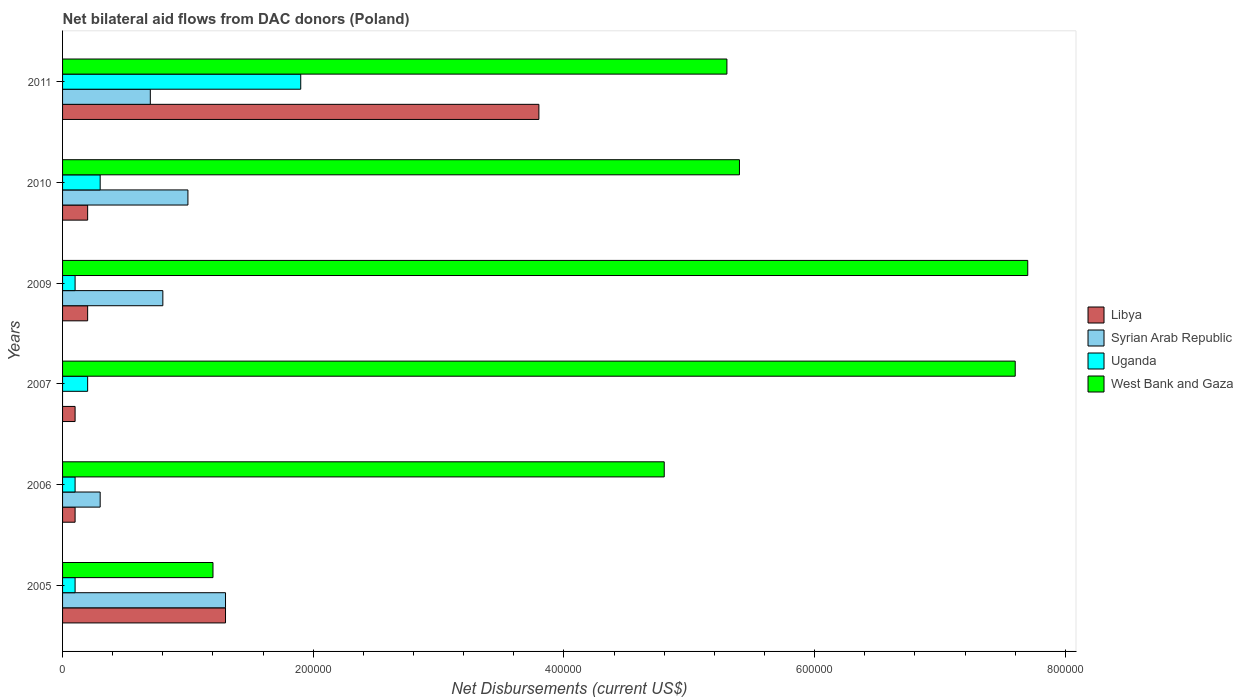How many groups of bars are there?
Keep it short and to the point. 6. Are the number of bars on each tick of the Y-axis equal?
Give a very brief answer. No. How many bars are there on the 1st tick from the bottom?
Offer a terse response. 4. In how many cases, is the number of bars for a given year not equal to the number of legend labels?
Make the answer very short. 1. What is the net bilateral aid flows in West Bank and Gaza in 2011?
Offer a terse response. 5.30e+05. Across all years, what is the maximum net bilateral aid flows in Uganda?
Offer a terse response. 1.90e+05. What is the difference between the net bilateral aid flows in Syrian Arab Republic in 2010 and the net bilateral aid flows in West Bank and Gaza in 2005?
Provide a succinct answer. -2.00e+04. What is the average net bilateral aid flows in West Bank and Gaza per year?
Offer a very short reply. 5.33e+05. In how many years, is the net bilateral aid flows in Libya greater than 760000 US$?
Your answer should be very brief. 0. What is the ratio of the net bilateral aid flows in West Bank and Gaza in 2005 to that in 2010?
Offer a terse response. 0.22. Is the net bilateral aid flows in Libya in 2007 less than that in 2009?
Keep it short and to the point. Yes. What is the difference between the highest and the lowest net bilateral aid flows in Syrian Arab Republic?
Provide a succinct answer. 1.30e+05. How many bars are there?
Give a very brief answer. 23. How many years are there in the graph?
Offer a terse response. 6. What is the difference between two consecutive major ticks on the X-axis?
Your answer should be compact. 2.00e+05. Are the values on the major ticks of X-axis written in scientific E-notation?
Provide a short and direct response. No. How are the legend labels stacked?
Offer a very short reply. Vertical. What is the title of the graph?
Offer a very short reply. Net bilateral aid flows from DAC donors (Poland). What is the label or title of the X-axis?
Offer a terse response. Net Disbursements (current US$). What is the Net Disbursements (current US$) of Uganda in 2005?
Make the answer very short. 10000. What is the Net Disbursements (current US$) of Libya in 2006?
Keep it short and to the point. 10000. What is the Net Disbursements (current US$) of Syrian Arab Republic in 2006?
Offer a terse response. 3.00e+04. What is the Net Disbursements (current US$) of Uganda in 2006?
Offer a terse response. 10000. What is the Net Disbursements (current US$) of Libya in 2007?
Make the answer very short. 10000. What is the Net Disbursements (current US$) of Uganda in 2007?
Offer a very short reply. 2.00e+04. What is the Net Disbursements (current US$) of West Bank and Gaza in 2007?
Ensure brevity in your answer.  7.60e+05. What is the Net Disbursements (current US$) of Libya in 2009?
Make the answer very short. 2.00e+04. What is the Net Disbursements (current US$) in Syrian Arab Republic in 2009?
Provide a succinct answer. 8.00e+04. What is the Net Disbursements (current US$) of Uganda in 2009?
Give a very brief answer. 10000. What is the Net Disbursements (current US$) of West Bank and Gaza in 2009?
Provide a short and direct response. 7.70e+05. What is the Net Disbursements (current US$) of Libya in 2010?
Your answer should be compact. 2.00e+04. What is the Net Disbursements (current US$) in Syrian Arab Republic in 2010?
Your response must be concise. 1.00e+05. What is the Net Disbursements (current US$) in West Bank and Gaza in 2010?
Keep it short and to the point. 5.40e+05. What is the Net Disbursements (current US$) in Syrian Arab Republic in 2011?
Your response must be concise. 7.00e+04. What is the Net Disbursements (current US$) in West Bank and Gaza in 2011?
Ensure brevity in your answer.  5.30e+05. Across all years, what is the maximum Net Disbursements (current US$) in Libya?
Ensure brevity in your answer.  3.80e+05. Across all years, what is the maximum Net Disbursements (current US$) in West Bank and Gaza?
Provide a succinct answer. 7.70e+05. Across all years, what is the minimum Net Disbursements (current US$) in Uganda?
Keep it short and to the point. 10000. What is the total Net Disbursements (current US$) in Libya in the graph?
Offer a very short reply. 5.70e+05. What is the total Net Disbursements (current US$) of Syrian Arab Republic in the graph?
Your response must be concise. 4.10e+05. What is the total Net Disbursements (current US$) of Uganda in the graph?
Offer a terse response. 2.70e+05. What is the total Net Disbursements (current US$) in West Bank and Gaza in the graph?
Offer a terse response. 3.20e+06. What is the difference between the Net Disbursements (current US$) in Libya in 2005 and that in 2006?
Offer a terse response. 1.20e+05. What is the difference between the Net Disbursements (current US$) in Syrian Arab Republic in 2005 and that in 2006?
Provide a short and direct response. 1.00e+05. What is the difference between the Net Disbursements (current US$) in West Bank and Gaza in 2005 and that in 2006?
Provide a succinct answer. -3.60e+05. What is the difference between the Net Disbursements (current US$) in West Bank and Gaza in 2005 and that in 2007?
Make the answer very short. -6.40e+05. What is the difference between the Net Disbursements (current US$) of Syrian Arab Republic in 2005 and that in 2009?
Make the answer very short. 5.00e+04. What is the difference between the Net Disbursements (current US$) in Uganda in 2005 and that in 2009?
Offer a very short reply. 0. What is the difference between the Net Disbursements (current US$) in West Bank and Gaza in 2005 and that in 2009?
Keep it short and to the point. -6.50e+05. What is the difference between the Net Disbursements (current US$) of Libya in 2005 and that in 2010?
Your answer should be compact. 1.10e+05. What is the difference between the Net Disbursements (current US$) in Syrian Arab Republic in 2005 and that in 2010?
Keep it short and to the point. 3.00e+04. What is the difference between the Net Disbursements (current US$) in Uganda in 2005 and that in 2010?
Your answer should be compact. -2.00e+04. What is the difference between the Net Disbursements (current US$) in West Bank and Gaza in 2005 and that in 2010?
Your answer should be very brief. -4.20e+05. What is the difference between the Net Disbursements (current US$) of Libya in 2005 and that in 2011?
Provide a succinct answer. -2.50e+05. What is the difference between the Net Disbursements (current US$) in Syrian Arab Republic in 2005 and that in 2011?
Ensure brevity in your answer.  6.00e+04. What is the difference between the Net Disbursements (current US$) of West Bank and Gaza in 2005 and that in 2011?
Keep it short and to the point. -4.10e+05. What is the difference between the Net Disbursements (current US$) in West Bank and Gaza in 2006 and that in 2007?
Offer a very short reply. -2.80e+05. What is the difference between the Net Disbursements (current US$) in Libya in 2006 and that in 2010?
Your response must be concise. -10000. What is the difference between the Net Disbursements (current US$) in Syrian Arab Republic in 2006 and that in 2010?
Offer a terse response. -7.00e+04. What is the difference between the Net Disbursements (current US$) of Uganda in 2006 and that in 2010?
Your answer should be compact. -2.00e+04. What is the difference between the Net Disbursements (current US$) in West Bank and Gaza in 2006 and that in 2010?
Provide a short and direct response. -6.00e+04. What is the difference between the Net Disbursements (current US$) of Libya in 2006 and that in 2011?
Provide a succinct answer. -3.70e+05. What is the difference between the Net Disbursements (current US$) of West Bank and Gaza in 2007 and that in 2009?
Make the answer very short. -10000. What is the difference between the Net Disbursements (current US$) of Uganda in 2007 and that in 2010?
Your response must be concise. -10000. What is the difference between the Net Disbursements (current US$) of Libya in 2007 and that in 2011?
Give a very brief answer. -3.70e+05. What is the difference between the Net Disbursements (current US$) in Uganda in 2007 and that in 2011?
Keep it short and to the point. -1.70e+05. What is the difference between the Net Disbursements (current US$) in West Bank and Gaza in 2007 and that in 2011?
Offer a terse response. 2.30e+05. What is the difference between the Net Disbursements (current US$) in Uganda in 2009 and that in 2010?
Your response must be concise. -2.00e+04. What is the difference between the Net Disbursements (current US$) of Libya in 2009 and that in 2011?
Offer a very short reply. -3.60e+05. What is the difference between the Net Disbursements (current US$) of Uganda in 2009 and that in 2011?
Give a very brief answer. -1.80e+05. What is the difference between the Net Disbursements (current US$) of Libya in 2010 and that in 2011?
Provide a succinct answer. -3.60e+05. What is the difference between the Net Disbursements (current US$) of Syrian Arab Republic in 2010 and that in 2011?
Your response must be concise. 3.00e+04. What is the difference between the Net Disbursements (current US$) of West Bank and Gaza in 2010 and that in 2011?
Give a very brief answer. 10000. What is the difference between the Net Disbursements (current US$) in Libya in 2005 and the Net Disbursements (current US$) in West Bank and Gaza in 2006?
Offer a very short reply. -3.50e+05. What is the difference between the Net Disbursements (current US$) in Syrian Arab Republic in 2005 and the Net Disbursements (current US$) in Uganda in 2006?
Your answer should be very brief. 1.20e+05. What is the difference between the Net Disbursements (current US$) of Syrian Arab Republic in 2005 and the Net Disbursements (current US$) of West Bank and Gaza in 2006?
Your answer should be very brief. -3.50e+05. What is the difference between the Net Disbursements (current US$) in Uganda in 2005 and the Net Disbursements (current US$) in West Bank and Gaza in 2006?
Offer a very short reply. -4.70e+05. What is the difference between the Net Disbursements (current US$) in Libya in 2005 and the Net Disbursements (current US$) in Uganda in 2007?
Your answer should be very brief. 1.10e+05. What is the difference between the Net Disbursements (current US$) in Libya in 2005 and the Net Disbursements (current US$) in West Bank and Gaza in 2007?
Give a very brief answer. -6.30e+05. What is the difference between the Net Disbursements (current US$) in Syrian Arab Republic in 2005 and the Net Disbursements (current US$) in West Bank and Gaza in 2007?
Provide a short and direct response. -6.30e+05. What is the difference between the Net Disbursements (current US$) of Uganda in 2005 and the Net Disbursements (current US$) of West Bank and Gaza in 2007?
Make the answer very short. -7.50e+05. What is the difference between the Net Disbursements (current US$) of Libya in 2005 and the Net Disbursements (current US$) of West Bank and Gaza in 2009?
Provide a succinct answer. -6.40e+05. What is the difference between the Net Disbursements (current US$) of Syrian Arab Republic in 2005 and the Net Disbursements (current US$) of West Bank and Gaza in 2009?
Your response must be concise. -6.40e+05. What is the difference between the Net Disbursements (current US$) of Uganda in 2005 and the Net Disbursements (current US$) of West Bank and Gaza in 2009?
Your response must be concise. -7.60e+05. What is the difference between the Net Disbursements (current US$) in Libya in 2005 and the Net Disbursements (current US$) in West Bank and Gaza in 2010?
Provide a succinct answer. -4.10e+05. What is the difference between the Net Disbursements (current US$) of Syrian Arab Republic in 2005 and the Net Disbursements (current US$) of West Bank and Gaza in 2010?
Your response must be concise. -4.10e+05. What is the difference between the Net Disbursements (current US$) in Uganda in 2005 and the Net Disbursements (current US$) in West Bank and Gaza in 2010?
Keep it short and to the point. -5.30e+05. What is the difference between the Net Disbursements (current US$) in Libya in 2005 and the Net Disbursements (current US$) in Uganda in 2011?
Offer a very short reply. -6.00e+04. What is the difference between the Net Disbursements (current US$) of Libya in 2005 and the Net Disbursements (current US$) of West Bank and Gaza in 2011?
Your response must be concise. -4.00e+05. What is the difference between the Net Disbursements (current US$) in Syrian Arab Republic in 2005 and the Net Disbursements (current US$) in Uganda in 2011?
Provide a succinct answer. -6.00e+04. What is the difference between the Net Disbursements (current US$) of Syrian Arab Republic in 2005 and the Net Disbursements (current US$) of West Bank and Gaza in 2011?
Provide a short and direct response. -4.00e+05. What is the difference between the Net Disbursements (current US$) in Uganda in 2005 and the Net Disbursements (current US$) in West Bank and Gaza in 2011?
Give a very brief answer. -5.20e+05. What is the difference between the Net Disbursements (current US$) in Libya in 2006 and the Net Disbursements (current US$) in Uganda in 2007?
Make the answer very short. -10000. What is the difference between the Net Disbursements (current US$) in Libya in 2006 and the Net Disbursements (current US$) in West Bank and Gaza in 2007?
Keep it short and to the point. -7.50e+05. What is the difference between the Net Disbursements (current US$) in Syrian Arab Republic in 2006 and the Net Disbursements (current US$) in West Bank and Gaza in 2007?
Provide a short and direct response. -7.30e+05. What is the difference between the Net Disbursements (current US$) in Uganda in 2006 and the Net Disbursements (current US$) in West Bank and Gaza in 2007?
Provide a short and direct response. -7.50e+05. What is the difference between the Net Disbursements (current US$) of Libya in 2006 and the Net Disbursements (current US$) of West Bank and Gaza in 2009?
Ensure brevity in your answer.  -7.60e+05. What is the difference between the Net Disbursements (current US$) in Syrian Arab Republic in 2006 and the Net Disbursements (current US$) in West Bank and Gaza in 2009?
Offer a terse response. -7.40e+05. What is the difference between the Net Disbursements (current US$) in Uganda in 2006 and the Net Disbursements (current US$) in West Bank and Gaza in 2009?
Provide a short and direct response. -7.60e+05. What is the difference between the Net Disbursements (current US$) of Libya in 2006 and the Net Disbursements (current US$) of Uganda in 2010?
Offer a terse response. -2.00e+04. What is the difference between the Net Disbursements (current US$) in Libya in 2006 and the Net Disbursements (current US$) in West Bank and Gaza in 2010?
Offer a terse response. -5.30e+05. What is the difference between the Net Disbursements (current US$) of Syrian Arab Republic in 2006 and the Net Disbursements (current US$) of Uganda in 2010?
Ensure brevity in your answer.  0. What is the difference between the Net Disbursements (current US$) of Syrian Arab Republic in 2006 and the Net Disbursements (current US$) of West Bank and Gaza in 2010?
Keep it short and to the point. -5.10e+05. What is the difference between the Net Disbursements (current US$) in Uganda in 2006 and the Net Disbursements (current US$) in West Bank and Gaza in 2010?
Keep it short and to the point. -5.30e+05. What is the difference between the Net Disbursements (current US$) in Libya in 2006 and the Net Disbursements (current US$) in Syrian Arab Republic in 2011?
Your answer should be compact. -6.00e+04. What is the difference between the Net Disbursements (current US$) of Libya in 2006 and the Net Disbursements (current US$) of West Bank and Gaza in 2011?
Give a very brief answer. -5.20e+05. What is the difference between the Net Disbursements (current US$) of Syrian Arab Republic in 2006 and the Net Disbursements (current US$) of West Bank and Gaza in 2011?
Your answer should be very brief. -5.00e+05. What is the difference between the Net Disbursements (current US$) of Uganda in 2006 and the Net Disbursements (current US$) of West Bank and Gaza in 2011?
Offer a very short reply. -5.20e+05. What is the difference between the Net Disbursements (current US$) of Libya in 2007 and the Net Disbursements (current US$) of Syrian Arab Republic in 2009?
Offer a very short reply. -7.00e+04. What is the difference between the Net Disbursements (current US$) of Libya in 2007 and the Net Disbursements (current US$) of West Bank and Gaza in 2009?
Offer a terse response. -7.60e+05. What is the difference between the Net Disbursements (current US$) of Uganda in 2007 and the Net Disbursements (current US$) of West Bank and Gaza in 2009?
Offer a very short reply. -7.50e+05. What is the difference between the Net Disbursements (current US$) of Libya in 2007 and the Net Disbursements (current US$) of West Bank and Gaza in 2010?
Your response must be concise. -5.30e+05. What is the difference between the Net Disbursements (current US$) in Uganda in 2007 and the Net Disbursements (current US$) in West Bank and Gaza in 2010?
Give a very brief answer. -5.20e+05. What is the difference between the Net Disbursements (current US$) in Libya in 2007 and the Net Disbursements (current US$) in West Bank and Gaza in 2011?
Your answer should be compact. -5.20e+05. What is the difference between the Net Disbursements (current US$) in Uganda in 2007 and the Net Disbursements (current US$) in West Bank and Gaza in 2011?
Give a very brief answer. -5.10e+05. What is the difference between the Net Disbursements (current US$) in Libya in 2009 and the Net Disbursements (current US$) in Uganda in 2010?
Provide a succinct answer. -10000. What is the difference between the Net Disbursements (current US$) of Libya in 2009 and the Net Disbursements (current US$) of West Bank and Gaza in 2010?
Give a very brief answer. -5.20e+05. What is the difference between the Net Disbursements (current US$) in Syrian Arab Republic in 2009 and the Net Disbursements (current US$) in Uganda in 2010?
Make the answer very short. 5.00e+04. What is the difference between the Net Disbursements (current US$) in Syrian Arab Republic in 2009 and the Net Disbursements (current US$) in West Bank and Gaza in 2010?
Offer a very short reply. -4.60e+05. What is the difference between the Net Disbursements (current US$) in Uganda in 2009 and the Net Disbursements (current US$) in West Bank and Gaza in 2010?
Ensure brevity in your answer.  -5.30e+05. What is the difference between the Net Disbursements (current US$) in Libya in 2009 and the Net Disbursements (current US$) in West Bank and Gaza in 2011?
Give a very brief answer. -5.10e+05. What is the difference between the Net Disbursements (current US$) of Syrian Arab Republic in 2009 and the Net Disbursements (current US$) of West Bank and Gaza in 2011?
Offer a terse response. -4.50e+05. What is the difference between the Net Disbursements (current US$) in Uganda in 2009 and the Net Disbursements (current US$) in West Bank and Gaza in 2011?
Keep it short and to the point. -5.20e+05. What is the difference between the Net Disbursements (current US$) of Libya in 2010 and the Net Disbursements (current US$) of West Bank and Gaza in 2011?
Ensure brevity in your answer.  -5.10e+05. What is the difference between the Net Disbursements (current US$) of Syrian Arab Republic in 2010 and the Net Disbursements (current US$) of Uganda in 2011?
Make the answer very short. -9.00e+04. What is the difference between the Net Disbursements (current US$) in Syrian Arab Republic in 2010 and the Net Disbursements (current US$) in West Bank and Gaza in 2011?
Your answer should be compact. -4.30e+05. What is the difference between the Net Disbursements (current US$) in Uganda in 2010 and the Net Disbursements (current US$) in West Bank and Gaza in 2011?
Provide a short and direct response. -5.00e+05. What is the average Net Disbursements (current US$) of Libya per year?
Your response must be concise. 9.50e+04. What is the average Net Disbursements (current US$) in Syrian Arab Republic per year?
Provide a short and direct response. 6.83e+04. What is the average Net Disbursements (current US$) in Uganda per year?
Make the answer very short. 4.50e+04. What is the average Net Disbursements (current US$) of West Bank and Gaza per year?
Keep it short and to the point. 5.33e+05. In the year 2005, what is the difference between the Net Disbursements (current US$) of Libya and Net Disbursements (current US$) of West Bank and Gaza?
Offer a terse response. 10000. In the year 2005, what is the difference between the Net Disbursements (current US$) of Syrian Arab Republic and Net Disbursements (current US$) of West Bank and Gaza?
Your answer should be compact. 10000. In the year 2006, what is the difference between the Net Disbursements (current US$) of Libya and Net Disbursements (current US$) of Uganda?
Offer a terse response. 0. In the year 2006, what is the difference between the Net Disbursements (current US$) in Libya and Net Disbursements (current US$) in West Bank and Gaza?
Ensure brevity in your answer.  -4.70e+05. In the year 2006, what is the difference between the Net Disbursements (current US$) of Syrian Arab Republic and Net Disbursements (current US$) of Uganda?
Your answer should be very brief. 2.00e+04. In the year 2006, what is the difference between the Net Disbursements (current US$) in Syrian Arab Republic and Net Disbursements (current US$) in West Bank and Gaza?
Your answer should be very brief. -4.50e+05. In the year 2006, what is the difference between the Net Disbursements (current US$) of Uganda and Net Disbursements (current US$) of West Bank and Gaza?
Keep it short and to the point. -4.70e+05. In the year 2007, what is the difference between the Net Disbursements (current US$) of Libya and Net Disbursements (current US$) of West Bank and Gaza?
Your answer should be very brief. -7.50e+05. In the year 2007, what is the difference between the Net Disbursements (current US$) of Uganda and Net Disbursements (current US$) of West Bank and Gaza?
Make the answer very short. -7.40e+05. In the year 2009, what is the difference between the Net Disbursements (current US$) in Libya and Net Disbursements (current US$) in West Bank and Gaza?
Offer a very short reply. -7.50e+05. In the year 2009, what is the difference between the Net Disbursements (current US$) in Syrian Arab Republic and Net Disbursements (current US$) in West Bank and Gaza?
Offer a very short reply. -6.90e+05. In the year 2009, what is the difference between the Net Disbursements (current US$) in Uganda and Net Disbursements (current US$) in West Bank and Gaza?
Provide a short and direct response. -7.60e+05. In the year 2010, what is the difference between the Net Disbursements (current US$) in Libya and Net Disbursements (current US$) in Syrian Arab Republic?
Your response must be concise. -8.00e+04. In the year 2010, what is the difference between the Net Disbursements (current US$) in Libya and Net Disbursements (current US$) in Uganda?
Your answer should be very brief. -10000. In the year 2010, what is the difference between the Net Disbursements (current US$) in Libya and Net Disbursements (current US$) in West Bank and Gaza?
Provide a succinct answer. -5.20e+05. In the year 2010, what is the difference between the Net Disbursements (current US$) of Syrian Arab Republic and Net Disbursements (current US$) of West Bank and Gaza?
Offer a terse response. -4.40e+05. In the year 2010, what is the difference between the Net Disbursements (current US$) of Uganda and Net Disbursements (current US$) of West Bank and Gaza?
Ensure brevity in your answer.  -5.10e+05. In the year 2011, what is the difference between the Net Disbursements (current US$) in Libya and Net Disbursements (current US$) in West Bank and Gaza?
Give a very brief answer. -1.50e+05. In the year 2011, what is the difference between the Net Disbursements (current US$) in Syrian Arab Republic and Net Disbursements (current US$) in West Bank and Gaza?
Your answer should be very brief. -4.60e+05. What is the ratio of the Net Disbursements (current US$) of Libya in 2005 to that in 2006?
Provide a short and direct response. 13. What is the ratio of the Net Disbursements (current US$) of Syrian Arab Republic in 2005 to that in 2006?
Provide a short and direct response. 4.33. What is the ratio of the Net Disbursements (current US$) of Uganda in 2005 to that in 2006?
Provide a succinct answer. 1. What is the ratio of the Net Disbursements (current US$) of Libya in 2005 to that in 2007?
Your response must be concise. 13. What is the ratio of the Net Disbursements (current US$) of Uganda in 2005 to that in 2007?
Keep it short and to the point. 0.5. What is the ratio of the Net Disbursements (current US$) of West Bank and Gaza in 2005 to that in 2007?
Provide a short and direct response. 0.16. What is the ratio of the Net Disbursements (current US$) of Libya in 2005 to that in 2009?
Offer a terse response. 6.5. What is the ratio of the Net Disbursements (current US$) of Syrian Arab Republic in 2005 to that in 2009?
Give a very brief answer. 1.62. What is the ratio of the Net Disbursements (current US$) of West Bank and Gaza in 2005 to that in 2009?
Make the answer very short. 0.16. What is the ratio of the Net Disbursements (current US$) in Syrian Arab Republic in 2005 to that in 2010?
Ensure brevity in your answer.  1.3. What is the ratio of the Net Disbursements (current US$) of West Bank and Gaza in 2005 to that in 2010?
Give a very brief answer. 0.22. What is the ratio of the Net Disbursements (current US$) in Libya in 2005 to that in 2011?
Keep it short and to the point. 0.34. What is the ratio of the Net Disbursements (current US$) of Syrian Arab Republic in 2005 to that in 2011?
Keep it short and to the point. 1.86. What is the ratio of the Net Disbursements (current US$) of Uganda in 2005 to that in 2011?
Provide a succinct answer. 0.05. What is the ratio of the Net Disbursements (current US$) in West Bank and Gaza in 2005 to that in 2011?
Your response must be concise. 0.23. What is the ratio of the Net Disbursements (current US$) in Libya in 2006 to that in 2007?
Give a very brief answer. 1. What is the ratio of the Net Disbursements (current US$) of Uganda in 2006 to that in 2007?
Make the answer very short. 0.5. What is the ratio of the Net Disbursements (current US$) of West Bank and Gaza in 2006 to that in 2007?
Give a very brief answer. 0.63. What is the ratio of the Net Disbursements (current US$) in Libya in 2006 to that in 2009?
Offer a very short reply. 0.5. What is the ratio of the Net Disbursements (current US$) in Uganda in 2006 to that in 2009?
Your answer should be very brief. 1. What is the ratio of the Net Disbursements (current US$) of West Bank and Gaza in 2006 to that in 2009?
Ensure brevity in your answer.  0.62. What is the ratio of the Net Disbursements (current US$) in Libya in 2006 to that in 2010?
Give a very brief answer. 0.5. What is the ratio of the Net Disbursements (current US$) of Syrian Arab Republic in 2006 to that in 2010?
Provide a succinct answer. 0.3. What is the ratio of the Net Disbursements (current US$) of Uganda in 2006 to that in 2010?
Offer a very short reply. 0.33. What is the ratio of the Net Disbursements (current US$) of Libya in 2006 to that in 2011?
Your response must be concise. 0.03. What is the ratio of the Net Disbursements (current US$) of Syrian Arab Republic in 2006 to that in 2011?
Ensure brevity in your answer.  0.43. What is the ratio of the Net Disbursements (current US$) in Uganda in 2006 to that in 2011?
Your answer should be compact. 0.05. What is the ratio of the Net Disbursements (current US$) of West Bank and Gaza in 2006 to that in 2011?
Make the answer very short. 0.91. What is the ratio of the Net Disbursements (current US$) in Libya in 2007 to that in 2009?
Ensure brevity in your answer.  0.5. What is the ratio of the Net Disbursements (current US$) in West Bank and Gaza in 2007 to that in 2009?
Ensure brevity in your answer.  0.99. What is the ratio of the Net Disbursements (current US$) of Libya in 2007 to that in 2010?
Provide a succinct answer. 0.5. What is the ratio of the Net Disbursements (current US$) of Uganda in 2007 to that in 2010?
Make the answer very short. 0.67. What is the ratio of the Net Disbursements (current US$) of West Bank and Gaza in 2007 to that in 2010?
Your answer should be compact. 1.41. What is the ratio of the Net Disbursements (current US$) of Libya in 2007 to that in 2011?
Give a very brief answer. 0.03. What is the ratio of the Net Disbursements (current US$) in Uganda in 2007 to that in 2011?
Provide a succinct answer. 0.11. What is the ratio of the Net Disbursements (current US$) of West Bank and Gaza in 2007 to that in 2011?
Provide a short and direct response. 1.43. What is the ratio of the Net Disbursements (current US$) in Libya in 2009 to that in 2010?
Offer a terse response. 1. What is the ratio of the Net Disbursements (current US$) in West Bank and Gaza in 2009 to that in 2010?
Your answer should be compact. 1.43. What is the ratio of the Net Disbursements (current US$) in Libya in 2009 to that in 2011?
Make the answer very short. 0.05. What is the ratio of the Net Disbursements (current US$) in Syrian Arab Republic in 2009 to that in 2011?
Offer a terse response. 1.14. What is the ratio of the Net Disbursements (current US$) of Uganda in 2009 to that in 2011?
Offer a very short reply. 0.05. What is the ratio of the Net Disbursements (current US$) in West Bank and Gaza in 2009 to that in 2011?
Ensure brevity in your answer.  1.45. What is the ratio of the Net Disbursements (current US$) in Libya in 2010 to that in 2011?
Offer a very short reply. 0.05. What is the ratio of the Net Disbursements (current US$) of Syrian Arab Republic in 2010 to that in 2011?
Your answer should be compact. 1.43. What is the ratio of the Net Disbursements (current US$) of Uganda in 2010 to that in 2011?
Your answer should be very brief. 0.16. What is the ratio of the Net Disbursements (current US$) of West Bank and Gaza in 2010 to that in 2011?
Your response must be concise. 1.02. What is the difference between the highest and the second highest Net Disbursements (current US$) in Libya?
Offer a very short reply. 2.50e+05. What is the difference between the highest and the second highest Net Disbursements (current US$) of Uganda?
Provide a short and direct response. 1.60e+05. What is the difference between the highest and the lowest Net Disbursements (current US$) in West Bank and Gaza?
Provide a short and direct response. 6.50e+05. 